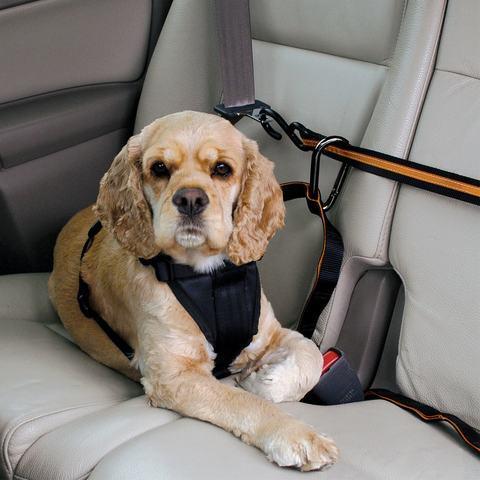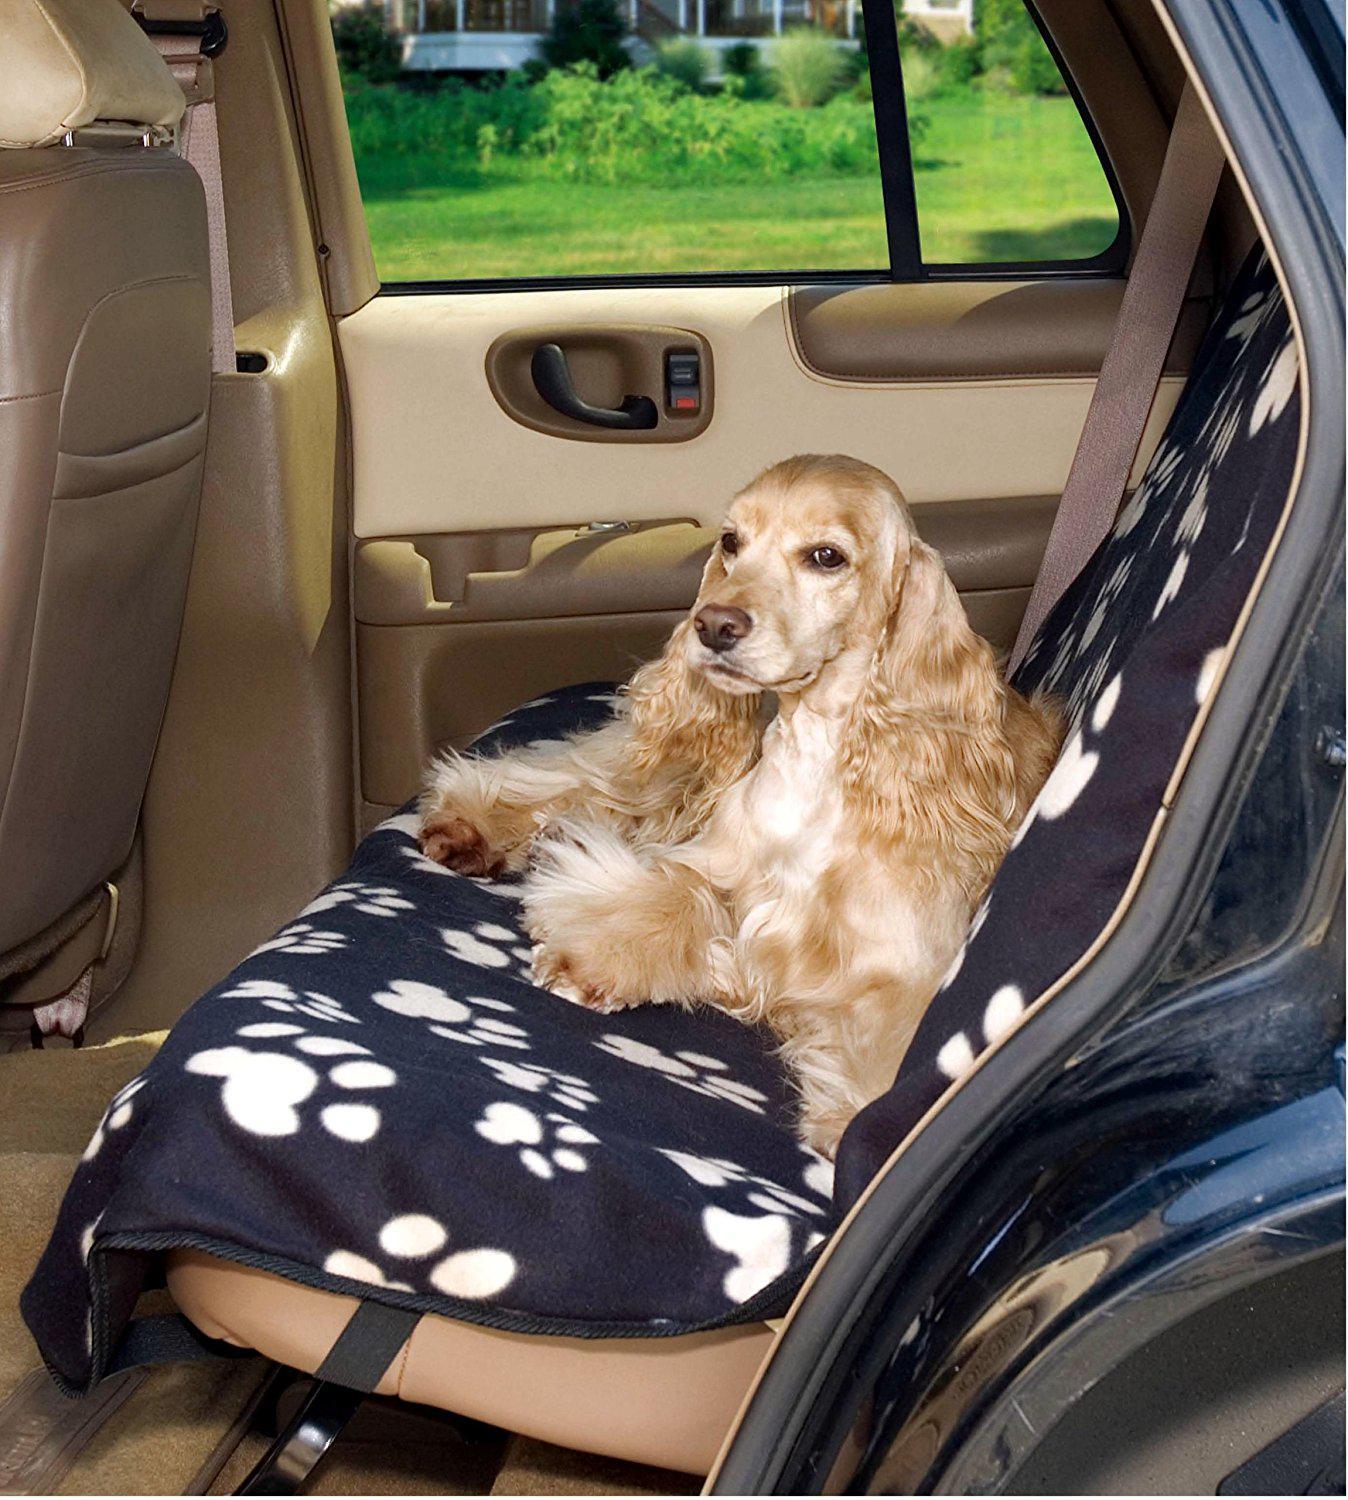The first image is the image on the left, the second image is the image on the right. Assess this claim about the two images: "Each image shows one spaniel riding in a car, and one image shows a spaniel sitting in a soft-sided box suspended over a seat by seat belts.". Correct or not? Answer yes or no. No. The first image is the image on the left, the second image is the image on the right. For the images displayed, is the sentence "One dog is riding in a carrier." factually correct? Answer yes or no. No. 